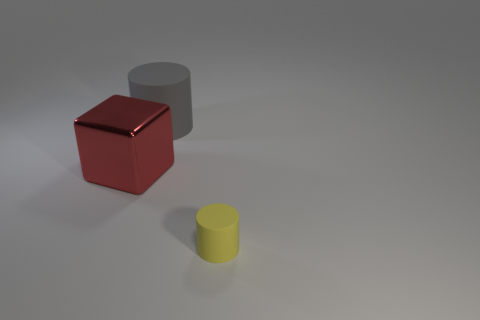Is there anything else that has the same material as the red block?
Provide a short and direct response. No. How many objects are yellow metal things or gray rubber cylinders?
Your answer should be compact. 1. What number of small objects are either gray cylinders or gray metal things?
Your answer should be compact. 0. There is a thing that is both behind the small yellow thing and in front of the big cylinder; how big is it?
Offer a terse response. Large. What number of other objects are there of the same material as the large red cube?
Your answer should be compact. 0. What is the shape of the object that is both in front of the big rubber thing and to the right of the large red metallic object?
Offer a terse response. Cylinder. There is a rubber cylinder that is behind the red block; is it the same size as the yellow matte object?
Keep it short and to the point. No. There is another object that is the same shape as the big rubber object; what material is it?
Make the answer very short. Rubber. Is the gray rubber object the same shape as the small rubber object?
Offer a very short reply. Yes. There is a thing that is left of the big rubber cylinder; what number of objects are left of it?
Give a very brief answer. 0. 